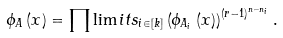<formula> <loc_0><loc_0><loc_500><loc_500>\phi _ { A } \left ( x \right ) = \prod \lim i t s _ { i \in \left [ k \right ] } \left ( \phi _ { A _ { i } } \left ( x \right ) \right ) ^ { \left ( r - 1 \right ) ^ { n - n _ { i } } } .</formula> 